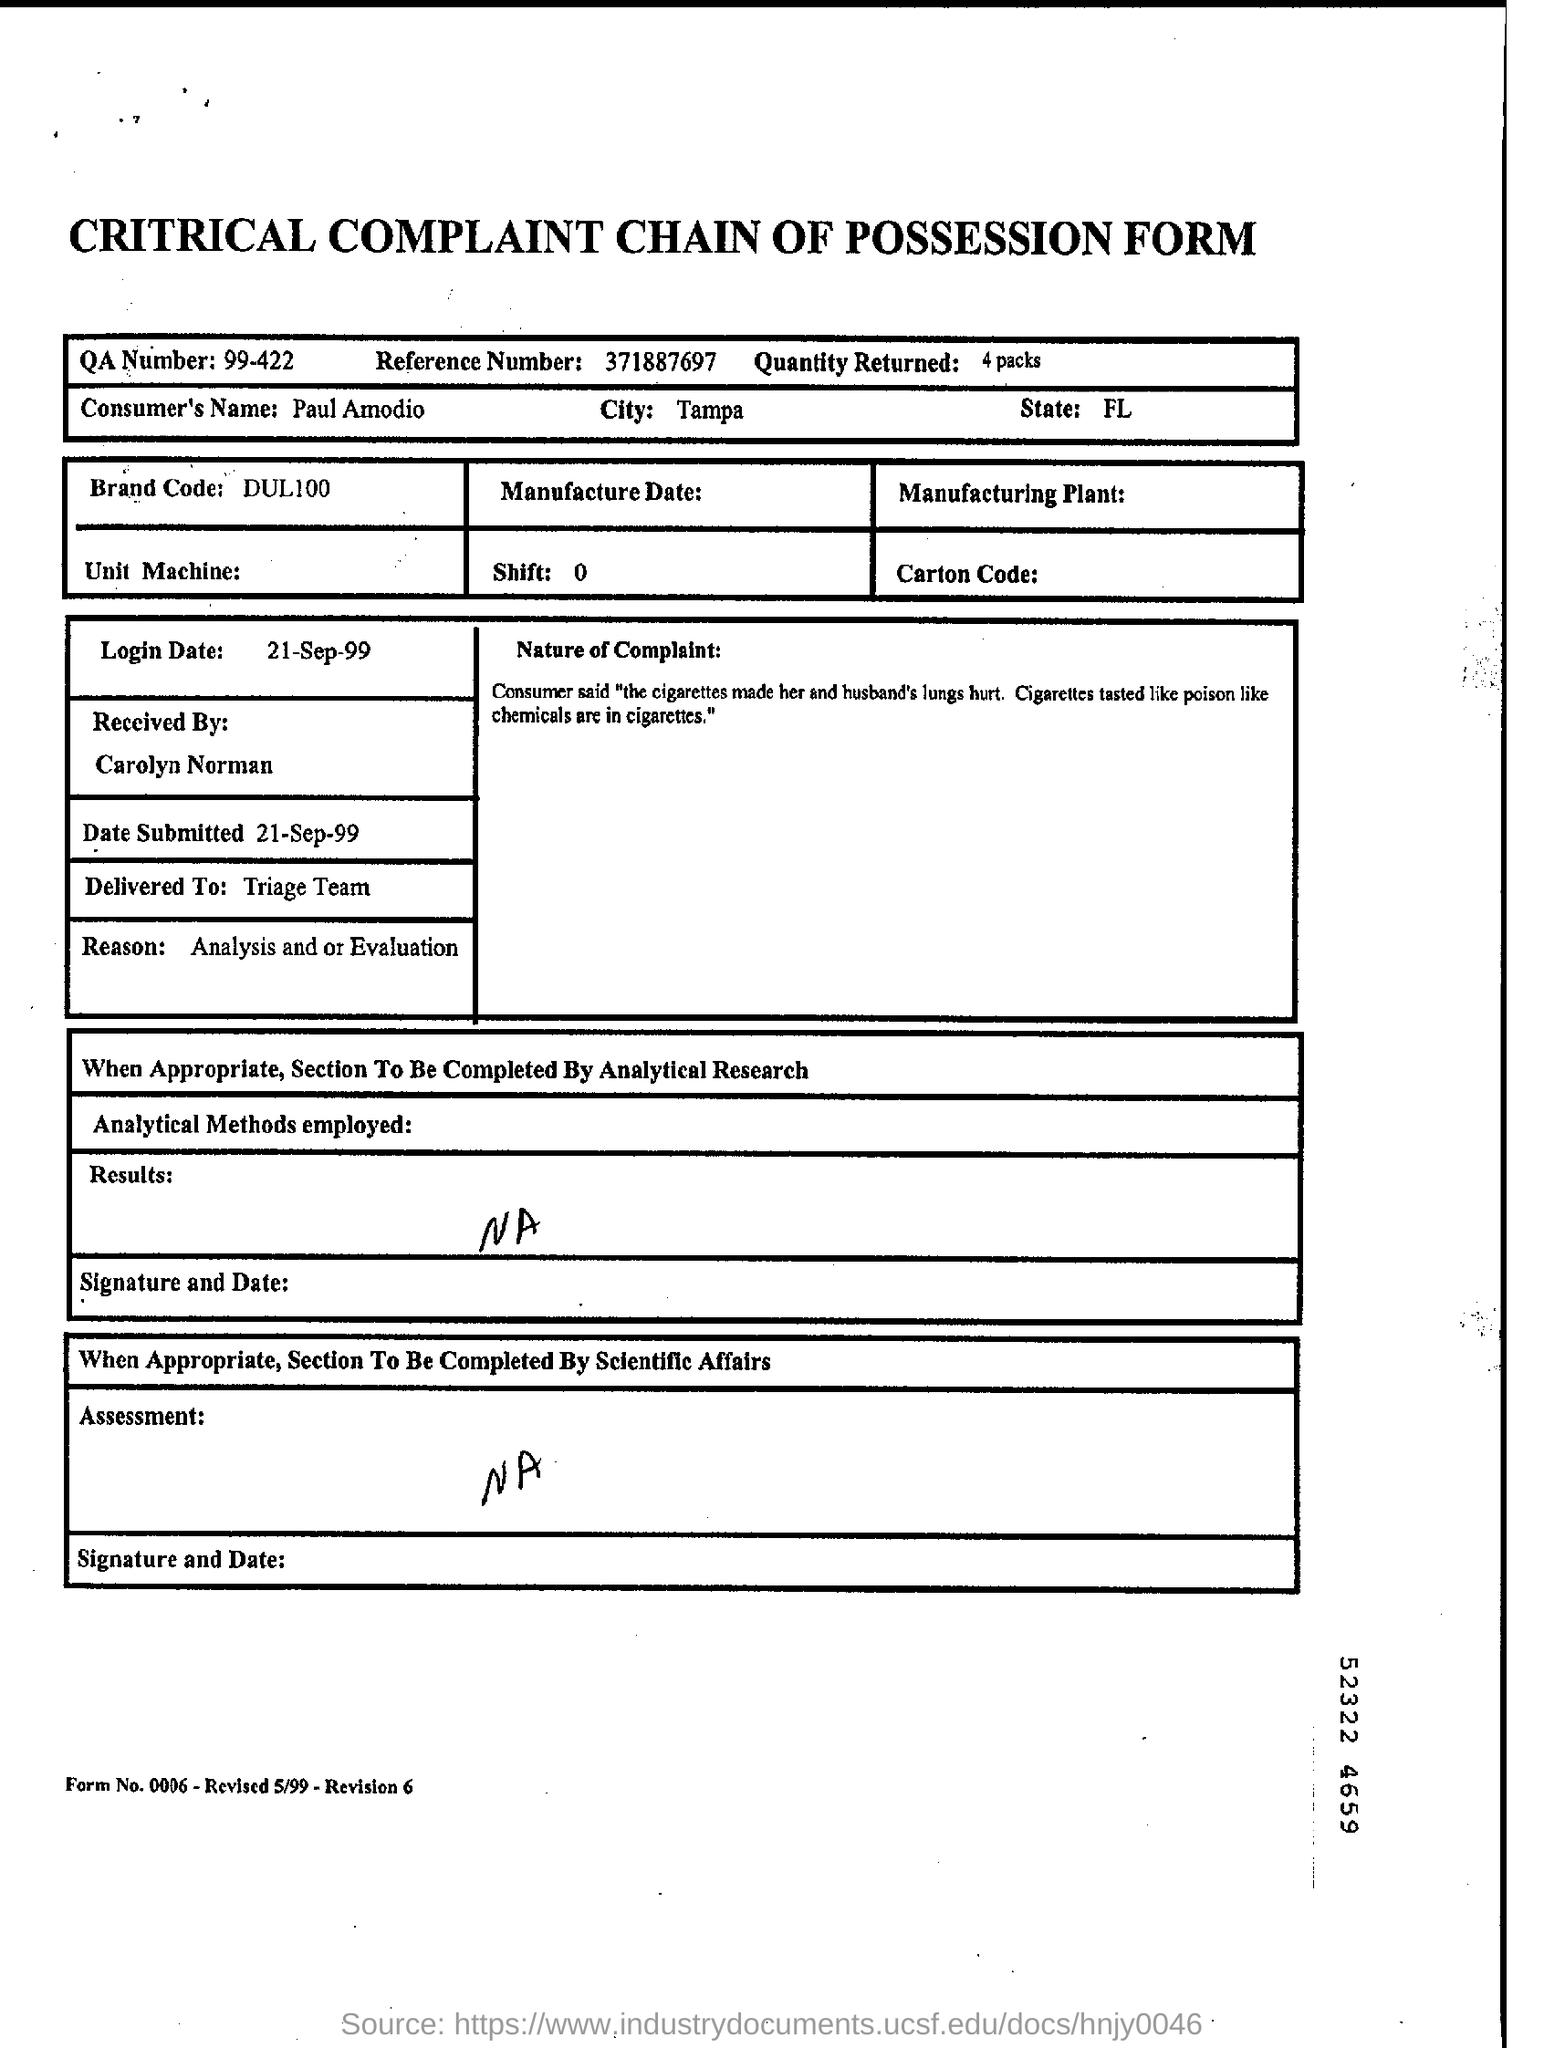What is the QA number?
Your answer should be very brief. 99-422. What is the reference number given?
Provide a succinct answer. 371887697. What is the consumer's name?
Your answer should be very brief. Paul Amodio. What is the brand code?
Your answer should be compact. DUL100. What is the login date?
Give a very brief answer. 21-SEP-99. 